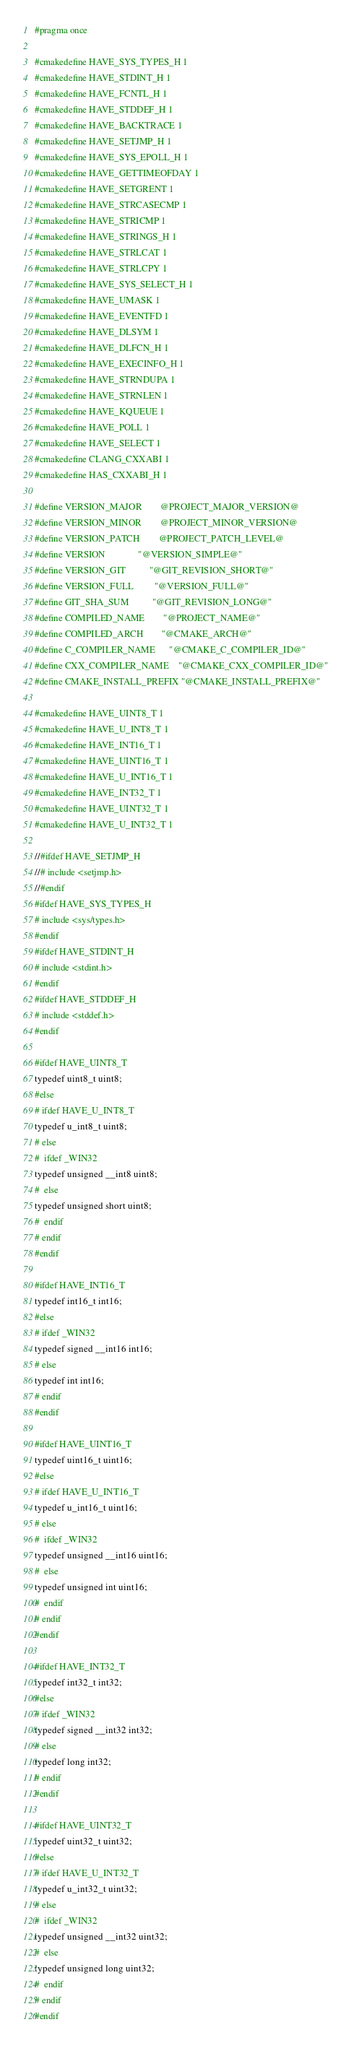Convert code to text. <code><loc_0><loc_0><loc_500><loc_500><_CMake_>#pragma once

#cmakedefine HAVE_SYS_TYPES_H 1
#cmakedefine HAVE_STDINT_H 1
#cmakedefine HAVE_FCNTL_H 1
#cmakedefine HAVE_STDDEF_H 1
#cmakedefine HAVE_BACKTRACE 1
#cmakedefine HAVE_SETJMP_H 1
#cmakedefine HAVE_SYS_EPOLL_H 1
#cmakedefine HAVE_GETTIMEOFDAY 1
#cmakedefine HAVE_SETGRENT 1
#cmakedefine HAVE_STRCASECMP 1
#cmakedefine HAVE_STRICMP 1
#cmakedefine HAVE_STRINGS_H 1
#cmakedefine HAVE_STRLCAT 1
#cmakedefine HAVE_STRLCPY 1
#cmakedefine HAVE_SYS_SELECT_H 1
#cmakedefine HAVE_UMASK 1
#cmakedefine HAVE_EVENTFD 1
#cmakedefine HAVE_DLSYM 1
#cmakedefine HAVE_DLFCN_H 1
#cmakedefine HAVE_EXECINFO_H 1
#cmakedefine HAVE_STRNDUPA 1
#cmakedefine HAVE_STRNLEN 1
#cmakedefine HAVE_KQUEUE 1
#cmakedefine HAVE_POLL 1
#cmakedefine HAVE_SELECT 1
#cmakedefine CLANG_CXXABI 1
#cmakedefine HAS_CXXABI_H 1

#define VERSION_MAJOR        @PROJECT_MAJOR_VERSION@
#define VERSION_MINOR        @PROJECT_MINOR_VERSION@
#define VERSION_PATCH        @PROJECT_PATCH_LEVEL@
#define VERSION              "@VERSION_SIMPLE@"
#define VERSION_GIT          "@GIT_REVISION_SHORT@"
#define VERSION_FULL         "@VERSION_FULL@"
#define GIT_SHA_SUM          "@GIT_REVISION_LONG@"
#define COMPILED_NAME        "@PROJECT_NAME@"
#define COMPILED_ARCH        "@CMAKE_ARCH@"
#define C_COMPILER_NAME      "@CMAKE_C_COMPILER_ID@"
#define CXX_COMPILER_NAME    "@CMAKE_CXX_COMPILER_ID@"
#define CMAKE_INSTALL_PREFIX "@CMAKE_INSTALL_PREFIX@"

#cmakedefine HAVE_UINT8_T 1
#cmakedefine HAVE_U_INT8_T 1
#cmakedefine HAVE_INT16_T 1
#cmakedefine HAVE_UINT16_T 1
#cmakedefine HAVE_U_INT16_T 1
#cmakedefine HAVE_INT32_T 1
#cmakedefine HAVE_UINT32_T 1
#cmakedefine HAVE_U_INT32_T 1

//#ifdef HAVE_SETJMP_H
//# include <setjmp.h>
//#endif
#ifdef HAVE_SYS_TYPES_H
# include <sys/types.h>
#endif
#ifdef HAVE_STDINT_H
# include <stdint.h>
#endif
#ifdef HAVE_STDDEF_H
# include <stddef.h>
#endif

#ifdef HAVE_UINT8_T
typedef uint8_t uint8;
#else
# ifdef HAVE_U_INT8_T
typedef u_int8_t uint8;
# else
#  ifdef _WIN32
typedef unsigned __int8 uint8;
#  else
typedef unsigned short uint8;
#  endif
# endif
#endif

#ifdef HAVE_INT16_T
typedef int16_t int16;
#else
# ifdef _WIN32
typedef signed __int16 int16;
# else
typedef int int16;
# endif
#endif

#ifdef HAVE_UINT16_T
typedef uint16_t uint16;
#else
# ifdef HAVE_U_INT16_T
typedef u_int16_t uint16;
# else
#  ifdef _WIN32
typedef unsigned __int16 uint16;
#  else
typedef unsigned int uint16;
#  endif
# endif
#endif

#ifdef HAVE_INT32_T
typedef int32_t int32;
#else
# ifdef _WIN32
typedef signed __int32 int32;
# else
typedef long int32;
# endif
#endif

#ifdef HAVE_UINT32_T
typedef uint32_t uint32;
#else
# ifdef HAVE_U_INT32_T
typedef u_int32_t uint32;
# else
#  ifdef _WIN32
typedef unsigned __int32 uint32;
#  else
typedef unsigned long uint32;
#  endif
# endif
#endif
</code> 